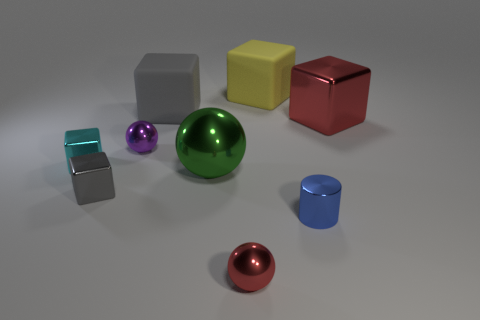Subtract all yellow blocks. How many blocks are left? 4 Subtract all small cyan metallic blocks. How many blocks are left? 4 Subtract all green cylinders. Subtract all blue balls. How many cylinders are left? 1 Add 1 blue rubber things. How many objects exist? 10 Subtract all cylinders. How many objects are left? 8 Add 5 small blue metallic cylinders. How many small blue metallic cylinders exist? 6 Subtract 0 gray spheres. How many objects are left? 9 Subtract all cyan matte balls. Subtract all big shiny objects. How many objects are left? 7 Add 8 tiny gray cubes. How many tiny gray cubes are left? 9 